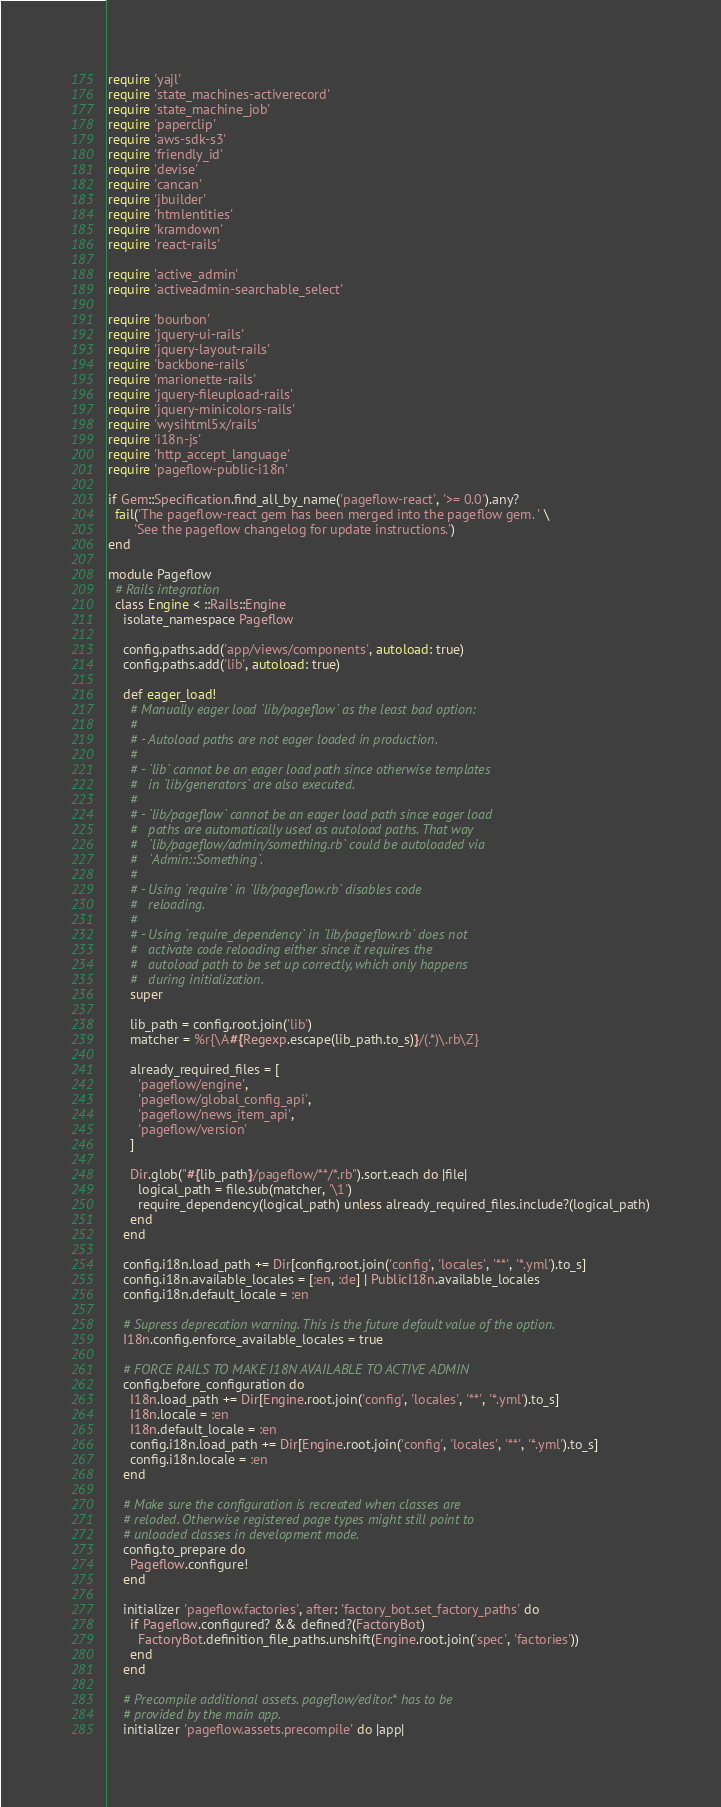<code> <loc_0><loc_0><loc_500><loc_500><_Ruby_>require 'yajl'
require 'state_machines-activerecord'
require 'state_machine_job'
require 'paperclip'
require 'aws-sdk-s3'
require 'friendly_id'
require 'devise'
require 'cancan'
require 'jbuilder'
require 'htmlentities'
require 'kramdown'
require 'react-rails'

require 'active_admin'
require 'activeadmin-searchable_select'

require 'bourbon'
require 'jquery-ui-rails'
require 'jquery-layout-rails'
require 'backbone-rails'
require 'marionette-rails'
require 'jquery-fileupload-rails'
require 'jquery-minicolors-rails'
require 'wysihtml5x/rails'
require 'i18n-js'
require 'http_accept_language'
require 'pageflow-public-i18n'

if Gem::Specification.find_all_by_name('pageflow-react', '>= 0.0').any?
  fail('The pageflow-react gem has been merged into the pageflow gem. ' \
       'See the pageflow changelog for update instructions.')
end

module Pageflow
  # Rails integration
  class Engine < ::Rails::Engine
    isolate_namespace Pageflow

    config.paths.add('app/views/components', autoload: true)
    config.paths.add('lib', autoload: true)

    def eager_load!
      # Manually eager load `lib/pageflow` as the least bad option:
      #
      # - Autoload paths are not eager loaded in production.
      #
      # - `lib` cannot be an eager load path since otherwise templates
      #   in `lib/generators` are also executed.
      #
      # - `lib/pageflow` cannot be an eager load path since eager load
      #   paths are automatically used as autoload paths. That way
      #   `lib/pageflow/admin/something.rb` could be autoloaded via
      #   `Admin::Something`.
      #
      # - Using `require` in `lib/pageflow.rb` disables code
      #   reloading.
      #
      # - Using `require_dependency` in `lib/pageflow.rb` does not
      #   activate code reloading either since it requires the
      #   autoload path to be set up correctly, which only happens
      #   during initialization.
      super

      lib_path = config.root.join('lib')
      matcher = %r{\A#{Regexp.escape(lib_path.to_s)}/(.*)\.rb\Z}

      already_required_files = [
        'pageflow/engine',
        'pageflow/global_config_api',
        'pageflow/news_item_api',
        'pageflow/version'
      ]

      Dir.glob("#{lib_path}/pageflow/**/*.rb").sort.each do |file|
        logical_path = file.sub(matcher, '\1')
        require_dependency(logical_path) unless already_required_files.include?(logical_path)
      end
    end

    config.i18n.load_path += Dir[config.root.join('config', 'locales', '**', '*.yml').to_s]
    config.i18n.available_locales = [:en, :de] | PublicI18n.available_locales
    config.i18n.default_locale = :en

    # Supress deprecation warning. This is the future default value of the option.
    I18n.config.enforce_available_locales = true

    # FORCE RAILS TO MAKE I18N AVAILABLE TO ACTIVE ADMIN
    config.before_configuration do
      I18n.load_path += Dir[Engine.root.join('config', 'locales', '**', '*.yml').to_s]
      I18n.locale = :en
      I18n.default_locale = :en
      config.i18n.load_path += Dir[Engine.root.join('config', 'locales', '**', '*.yml').to_s]
      config.i18n.locale = :en
    end

    # Make sure the configuration is recreated when classes are
    # reloded. Otherwise registered page types might still point to
    # unloaded classes in development mode.
    config.to_prepare do
      Pageflow.configure!
    end

    initializer 'pageflow.factories', after: 'factory_bot.set_factory_paths' do
      if Pageflow.configured? && defined?(FactoryBot)
        FactoryBot.definition_file_paths.unshift(Engine.root.join('spec', 'factories'))
      end
    end

    # Precompile additional assets. pageflow/editor.* has to be
    # provided by the main app.
    initializer 'pageflow.assets.precompile' do |app|</code> 